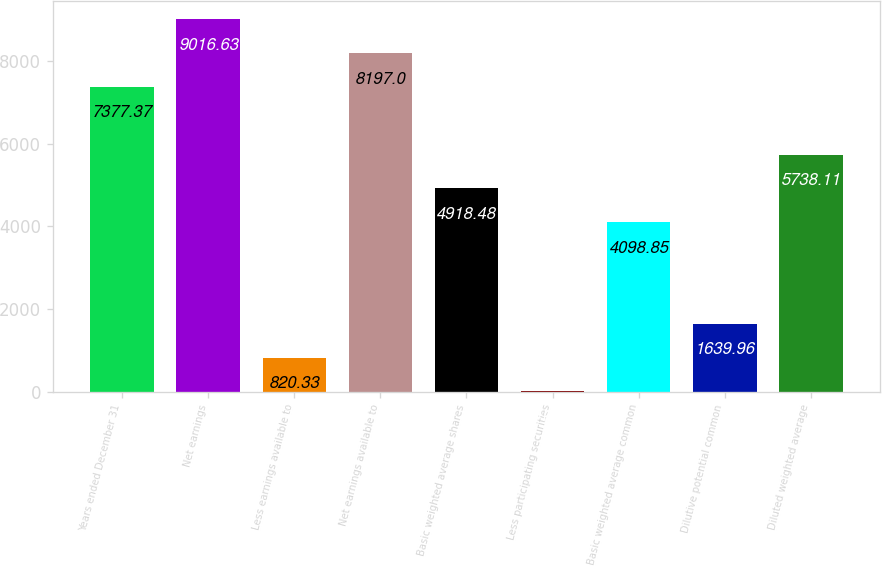<chart> <loc_0><loc_0><loc_500><loc_500><bar_chart><fcel>Years ended December 31<fcel>Net earnings<fcel>Less earnings available to<fcel>Net earnings available to<fcel>Basic weighted average shares<fcel>Less participating securities<fcel>Basic weighted average common<fcel>Dilutive potential common<fcel>Diluted weighted average<nl><fcel>7377.37<fcel>9016.63<fcel>820.33<fcel>8197<fcel>4918.48<fcel>0.7<fcel>4098.85<fcel>1639.96<fcel>5738.11<nl></chart> 